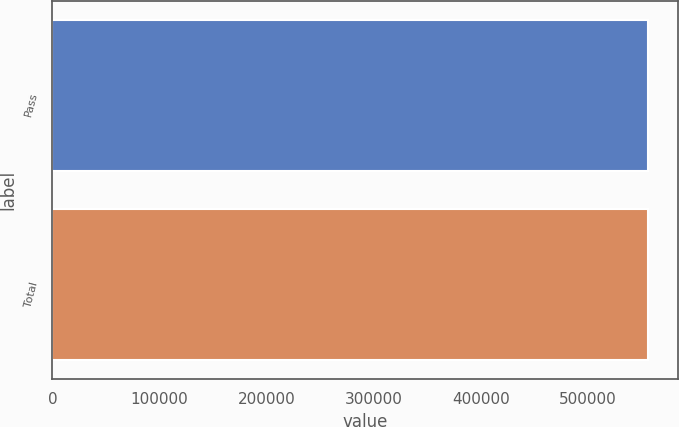<chart> <loc_0><loc_0><loc_500><loc_500><bar_chart><fcel>Pass<fcel>Total<nl><fcel>555805<fcel>555805<nl></chart> 